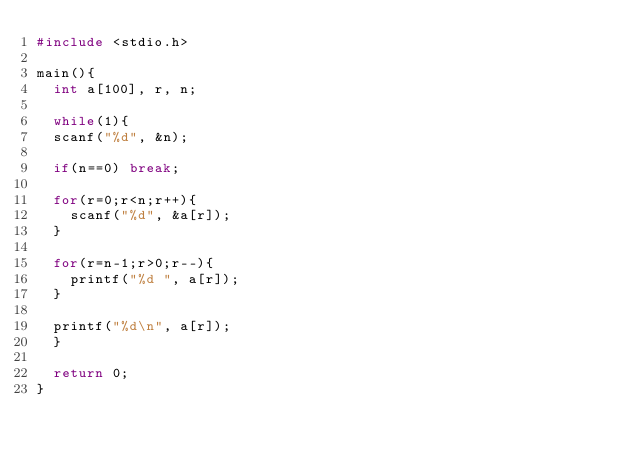<code> <loc_0><loc_0><loc_500><loc_500><_C_>#include <stdio.h>

main(){
  int a[100], r, n;

  while(1){
  scanf("%d", &n);

  if(n==0) break;

  for(r=0;r<n;r++){
    scanf("%d", &a[r]);
  }

  for(r=n-1;r>0;r--){
    printf("%d ", a[r]);
  }

  printf("%d\n", a[r]);
  }

  return 0;
}</code> 